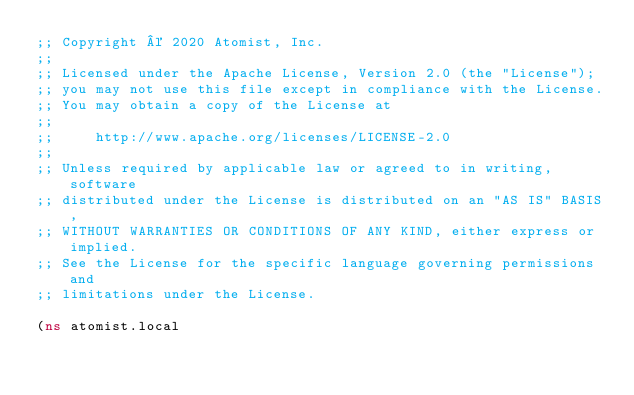Convert code to text. <code><loc_0><loc_0><loc_500><loc_500><_Clojure_>;; Copyright © 2020 Atomist, Inc.
;;
;; Licensed under the Apache License, Version 2.0 (the "License");
;; you may not use this file except in compliance with the License.
;; You may obtain a copy of the License at
;;
;;     http://www.apache.org/licenses/LICENSE-2.0
;;
;; Unless required by applicable law or agreed to in writing, software
;; distributed under the License is distributed on an "AS IS" BASIS,
;; WITHOUT WARRANTIES OR CONDITIONS OF ANY KIND, either express or implied.
;; See the License for the specific language governing permissions and
;; limitations under the License.

(ns atomist.local</code> 